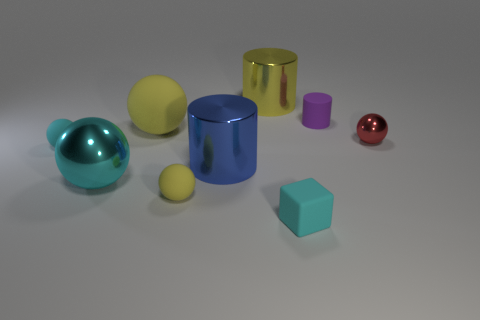Subtract all green cylinders. How many cyan balls are left? 2 Subtract all blue cylinders. How many cylinders are left? 2 Subtract all yellow spheres. How many spheres are left? 3 Subtract 3 balls. How many balls are left? 2 Add 1 large cyan metal objects. How many objects exist? 10 Subtract all green balls. Subtract all brown cubes. How many balls are left? 5 Subtract all cylinders. How many objects are left? 6 Add 7 purple matte cylinders. How many purple matte cylinders exist? 8 Subtract 0 gray cylinders. How many objects are left? 9 Subtract all metallic cylinders. Subtract all rubber spheres. How many objects are left? 4 